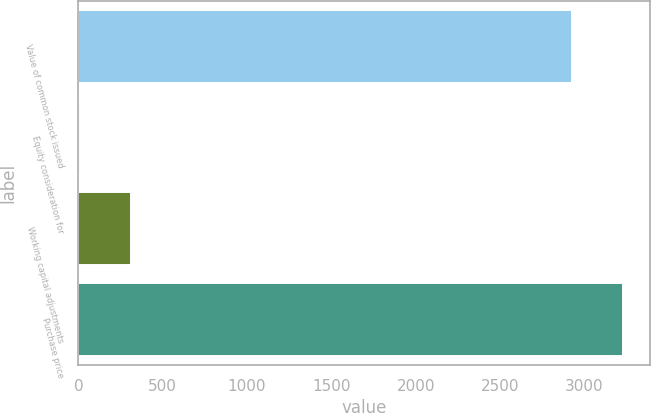<chart> <loc_0><loc_0><loc_500><loc_500><bar_chart><fcel>Value of common stock issued<fcel>Equity consideration for<fcel>Working capital adjustments<fcel>Purchase price<nl><fcel>2929<fcel>9<fcel>310<fcel>3230<nl></chart> 